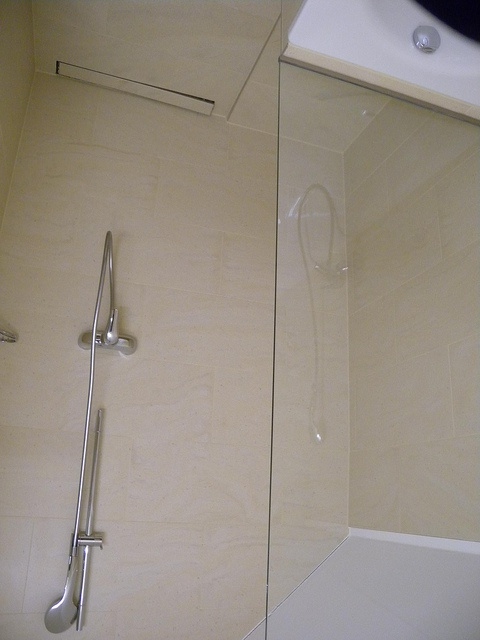Describe the objects in this image and their specific colors. I can see various objects in this image with different colors. 